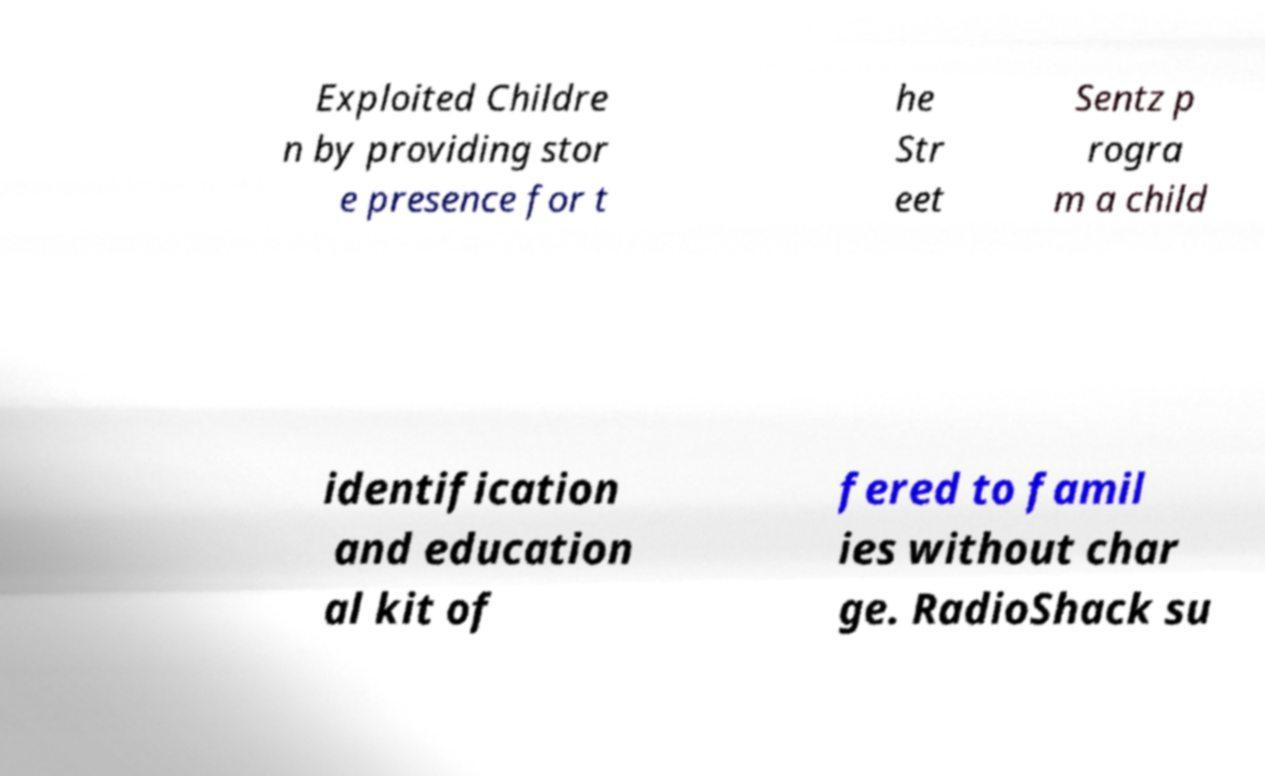What messages or text are displayed in this image? I need them in a readable, typed format. Exploited Childre n by providing stor e presence for t he Str eet Sentz p rogra m a child identification and education al kit of fered to famil ies without char ge. RadioShack su 